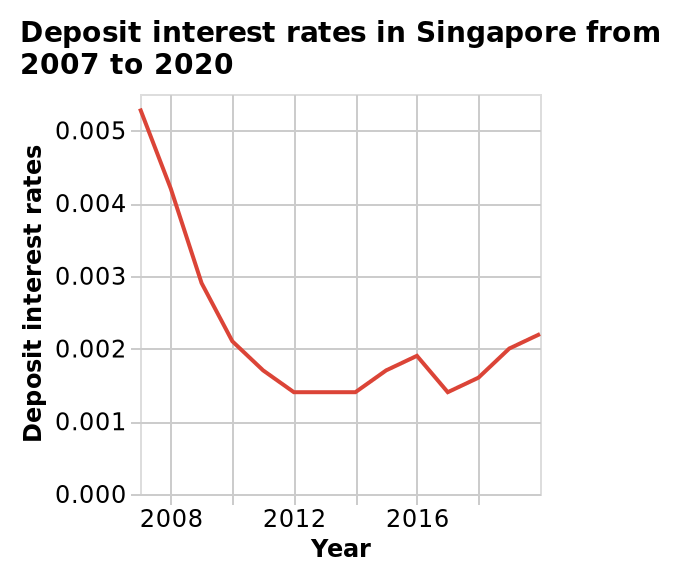<image>
What is the time range covered by the line graph? The time range covered by the line graph is from 2007 to 2020. What happened to the rates after 2016?  After 2016, there was a dip in the rates which then bounced back up to higher rates. 